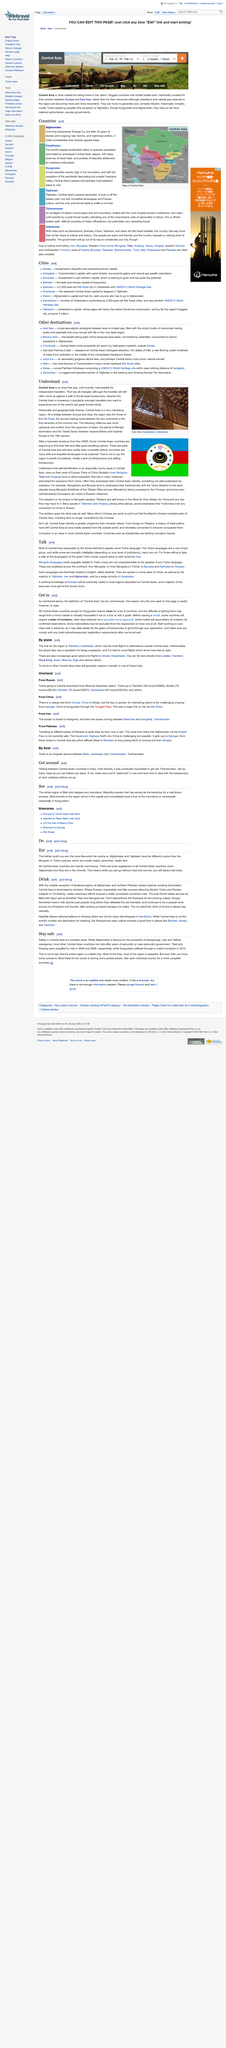Highlight a few significant elements in this photo. Throughout the history of Central Asia, several significant events have taken place that have shaped the region's political, social, and cultural landscape. The expansion of Islam, the period of Mongol domination, and the "Great Game" between imperial Britain and imperial Russia in the 19th century are some of the most significant events that have occurred in this region. These events have had a lasting impact on the region and continue to shape its present-day status. The photo was taken at Gur Amir in Samarkand, Uzbekistan. The Silk Road, a historical trade route connecting two continents during the first centuries of the common era, played a pivotal role in the exchange of goods, ideas, and culture between East and West. 